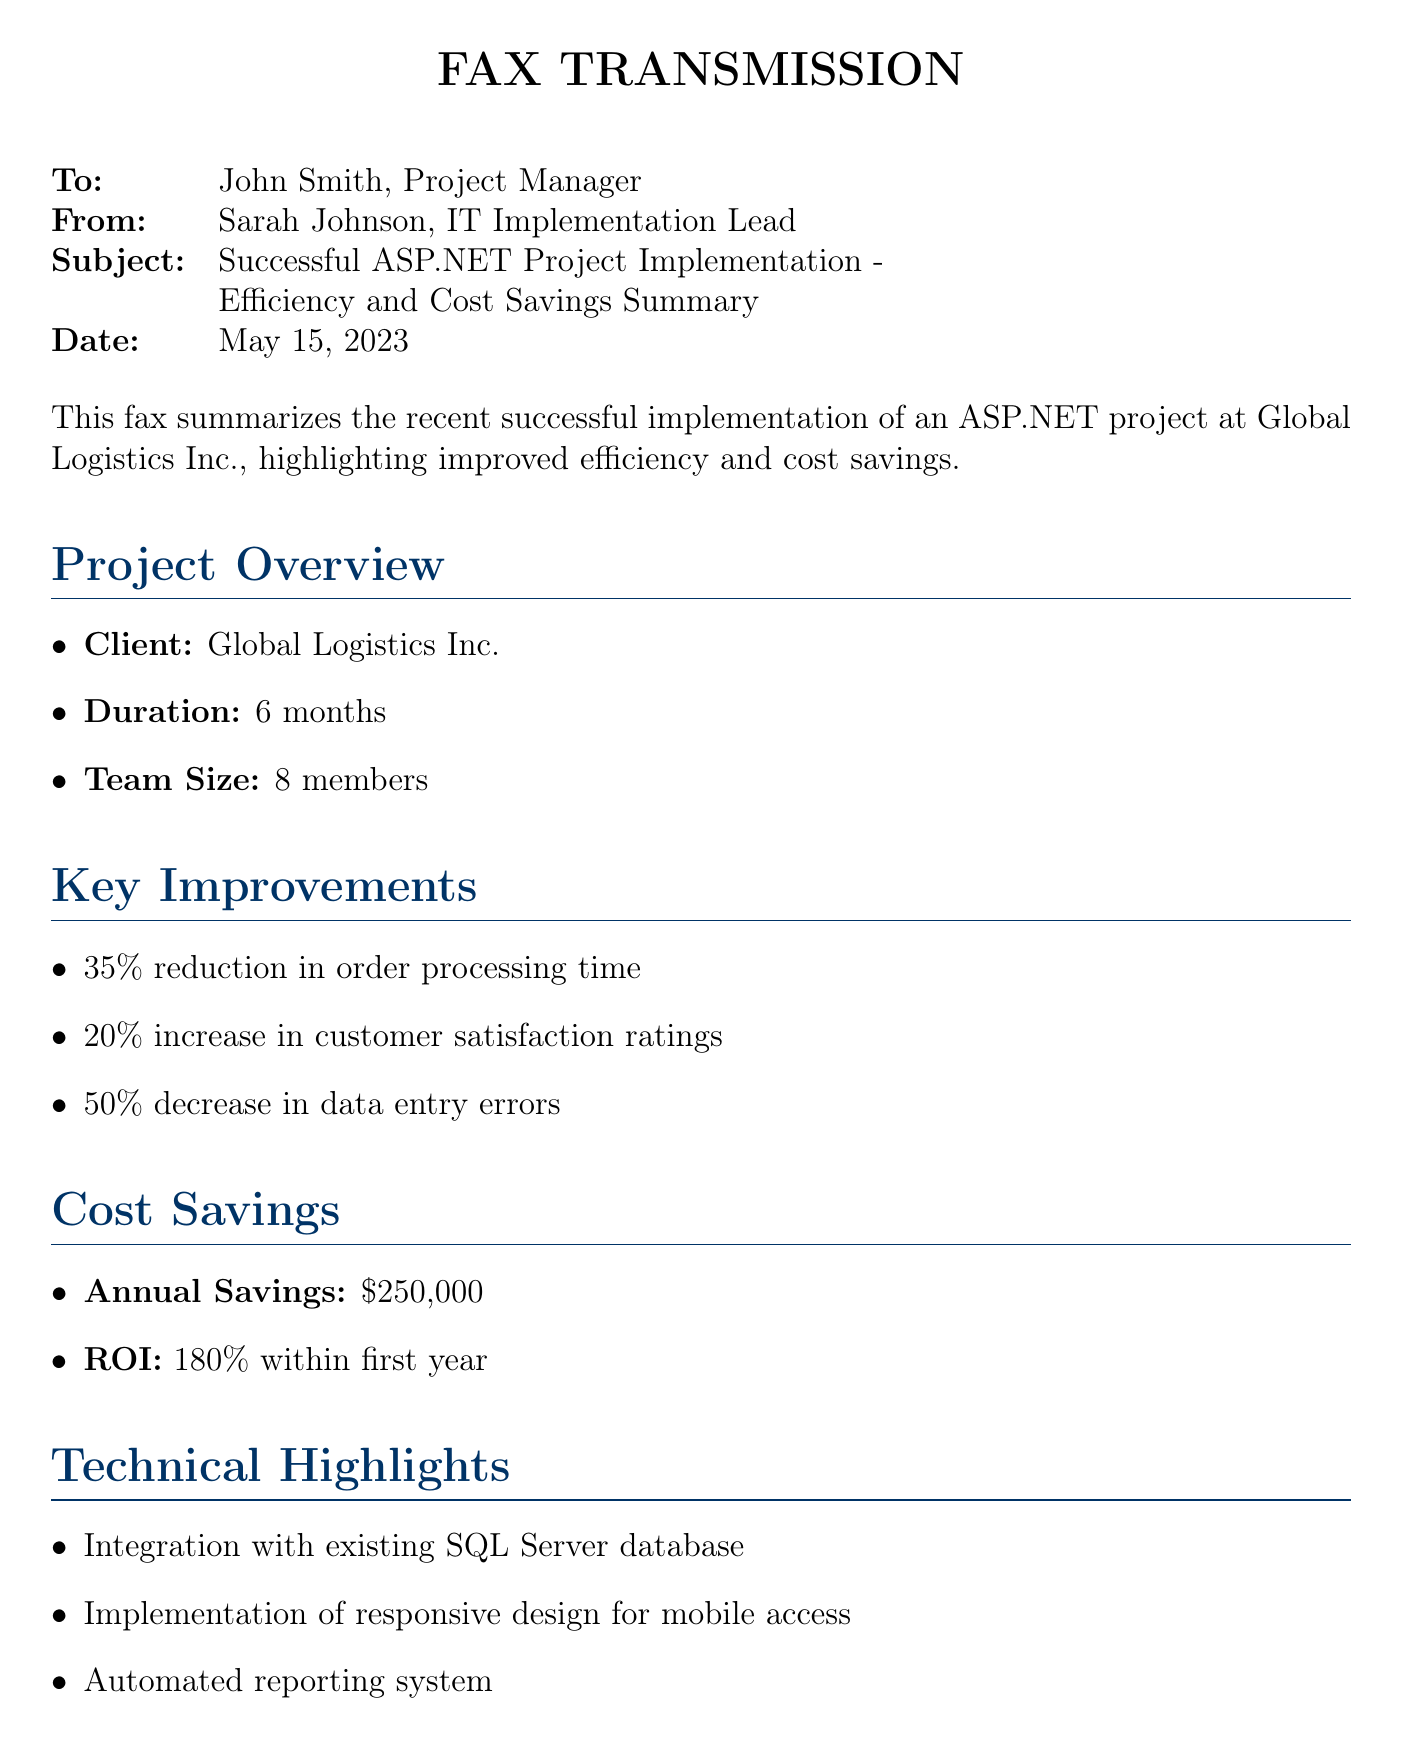What is the client name? The document states the client is Global Logistics Inc.
Answer: Global Logistics Inc What was the duration of the project? The document mentions that the project lasted for 6 months.
Answer: 6 months What is the annual savings generated from the project? According to the document, the annual savings is stated as $250,000.
Answer: $250,000 What percentage reduction in order processing time was achieved? The document indicates a 35% reduction in order processing time.
Answer: 35% What is the return on investment within the first year? The document specifies that the ROI is 180% within the first year.
Answer: 180% How many team members were involved in the project? The document lists that the team size was 8 members.
Answer: 8 members What percentage increase in customer satisfaction ratings was achieved? The document reports a 20% increase in customer satisfaction ratings.
Answer: 20% What new capability did the system provide in terms of shipment handling? The document explains that the system allows handling 30% more shipments without increasing staff.
Answer: 30% more shipments What was implemented for mobile access? The document notes that a responsive design was implemented for mobile access.
Answer: Responsive design 